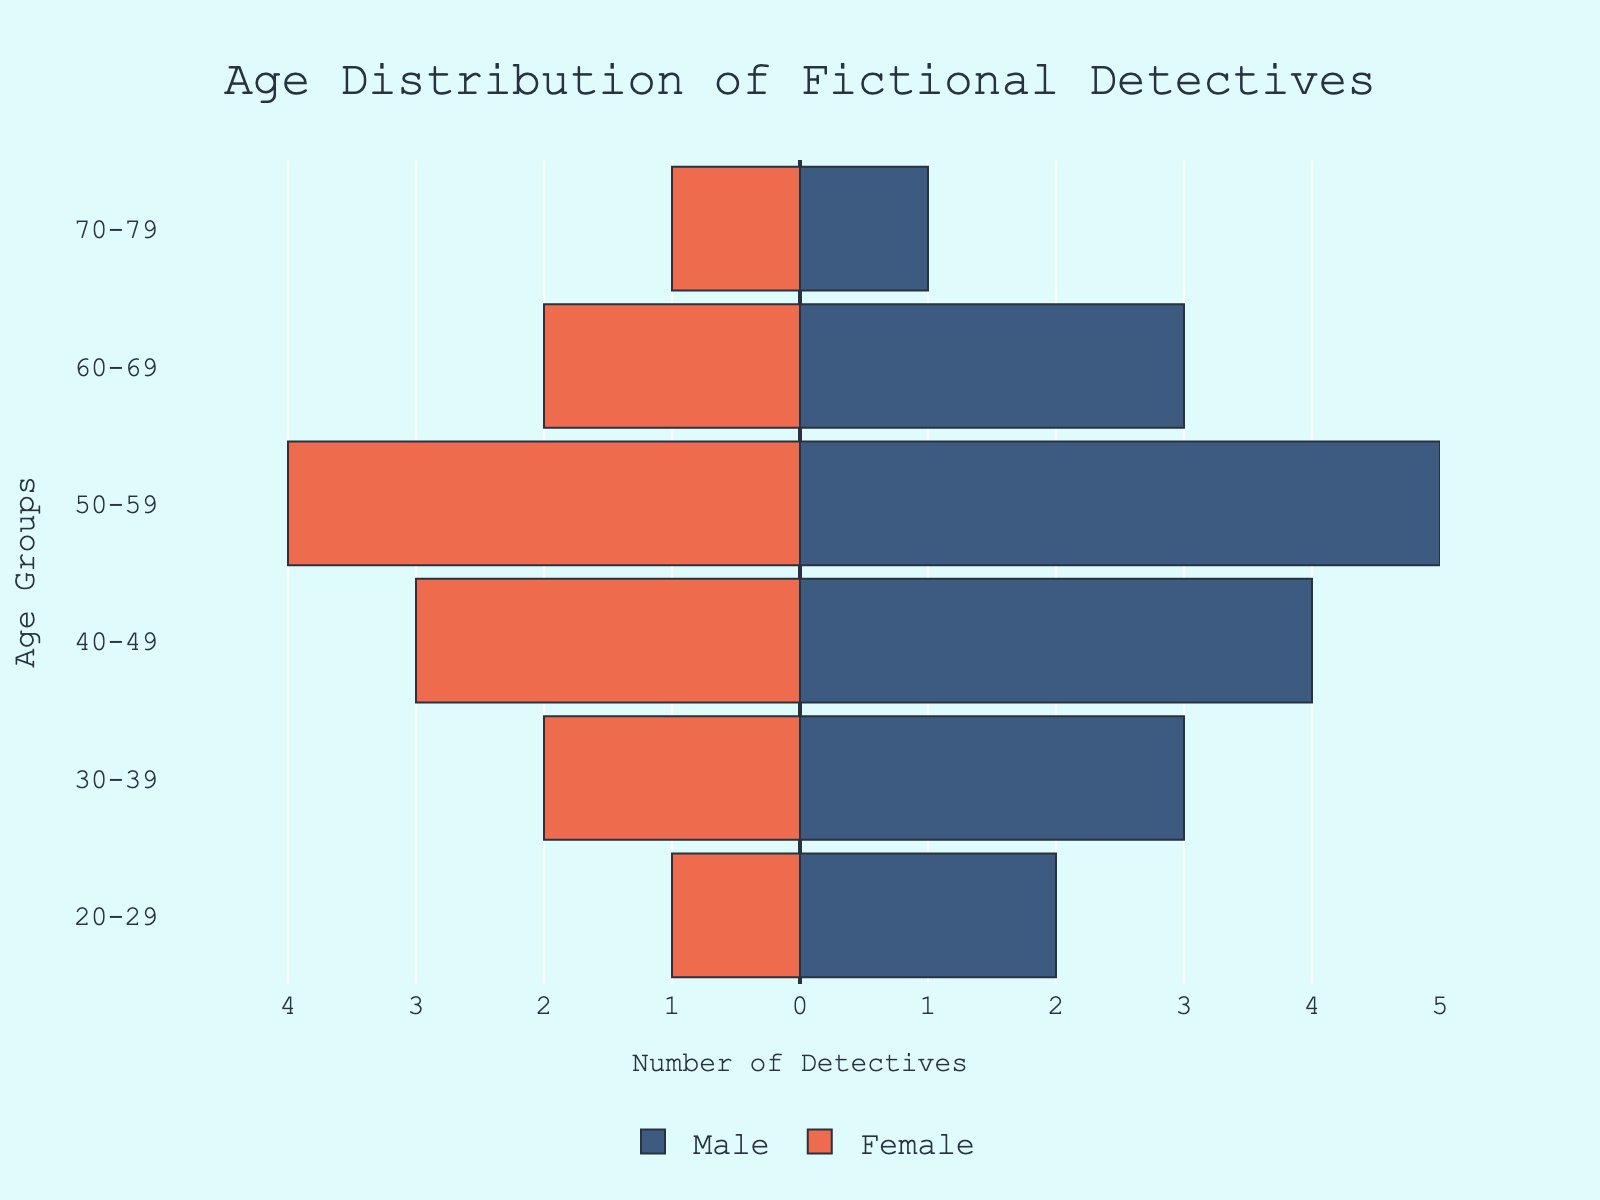What's the title of the figure? The title of the figure is located at the top center of the plot.
Answer: Age Distribution of Fictional Detectives Which age group has the highest number of male detectives? In the figure, the longest bar for male detectives indicates the highest number, which is found in the 50-59 age group.
Answer: 50-59 How many female detectives are there in the 60-69 age group? For the 60-69 age group, the bar length on the left (female side) shows the number of female detectives, which is 2.
Answer: 2 What is the total number of detectives in the 40-49 age group? Summing the male and female detectives in the 40-49 age group (4 males + 3 females) gives the total number.
Answer: 7 Compare the number of male and female detectives in the 70-79 age group. Which gender has more? Looking at the bars in the 70-79 age group, both male and female bars are equal in length, indicating equal numbers.
Answer: Equal In which age group do male detectives outnumber female detectives the most? The difference between the lengths of the male and female bars is largest in the 50-59 age group (5 males - 4 females = 1).
Answer: 50-59 What's the total number of male detectives across all age groups? Adding up the numbers of male detectives in all age groups (2 + 3 + 4 + 5 + 3 + 1) gives the total number.
Answer: 18 What's the total number of female detectives across all age groups? Adding up the numbers of female detectives in all age groups (1 + 2 + 3 + 4 + 2 + 1) gives the total number.
Answer: 13 What age group has the fewest detectives in total? The 20-29 and 70-79 age groups both have the smallest bars combined for males and females, each with a total of 3 detectives.
Answer: 20-29 and 70-79 Are there any age groups where the number of male and female detectives is equal? Checking all age groups, the bars are equal for males and females only in the 70-79 age group.
Answer: 70-79 